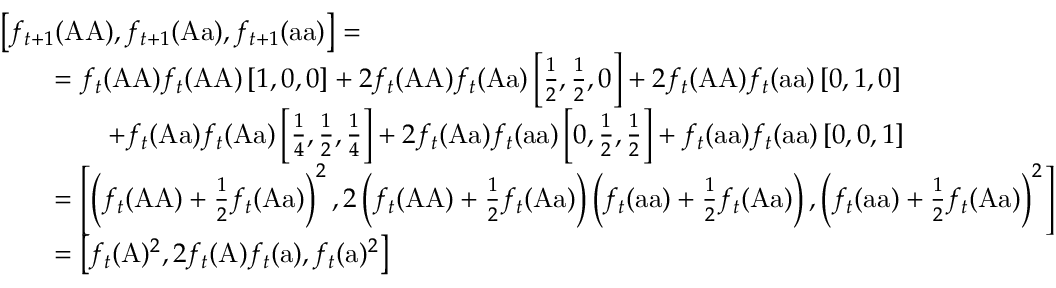Convert formula to latex. <formula><loc_0><loc_0><loc_500><loc_500>{ \begin{array} { r l } & { \left [ f _ { t + 1 } ( { A A } ) , f _ { t + 1 } ( { A a } ) , f _ { t + 1 } ( { a a } ) \right ] = } \\ & { \quad = f _ { t } ( { A A } ) f _ { t } ( { A A } ) \left [ 1 , 0 , 0 \right ] + 2 f _ { t } ( { A A } ) f _ { t } ( { A a } ) \left [ { \frac { 1 } { 2 } } , { \frac { 1 } { 2 } } , 0 \right ] + 2 f _ { t } ( { A A } ) f _ { t } ( { a a } ) \left [ 0 , 1 , 0 \right ] } \\ & { \quad + f _ { t } ( { A a } ) f _ { t } ( { A a } ) \left [ { \frac { 1 } { 4 } } , { \frac { 1 } { 2 } } , { \frac { 1 } { 4 } } \right ] + 2 f _ { t } ( { A a } ) f _ { t } ( { a a } ) \left [ 0 , { \frac { 1 } { 2 } } , { \frac { 1 } { 2 } } \right ] + f _ { t } ( { a a } ) f _ { t } ( { a a } ) \left [ 0 , 0 , 1 \right ] } \\ & { \quad = \left [ \left ( f _ { t } ( { A A } ) + { \frac { 1 } { 2 } } f _ { t } ( { A a } ) \right ) ^ { 2 } , 2 \left ( f _ { t } ( { A A } ) + { \frac { 1 } { 2 } } f _ { t } ( { A a } ) \right ) \left ( f _ { t } ( { a a } ) + { \frac { 1 } { 2 } } f _ { t } ( { A a } ) \right ) , \left ( f _ { t } ( { a a } ) + { \frac { 1 } { 2 } } f _ { t } ( { A a } ) \right ) ^ { 2 } \right ] } \\ & { \quad = \left [ f _ { t } ( { A } ) ^ { 2 } , 2 f _ { t } ( { A } ) f _ { t } ( { a } ) , f _ { t } ( { a } ) ^ { 2 } \right ] } \end{array} }</formula> 